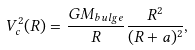Convert formula to latex. <formula><loc_0><loc_0><loc_500><loc_500>V _ { c } ^ { 2 } ( R ) = \frac { G M _ { b u l g e } } { R } \frac { R ^ { 2 } } { ( R + a ) ^ { 2 } } ,</formula> 